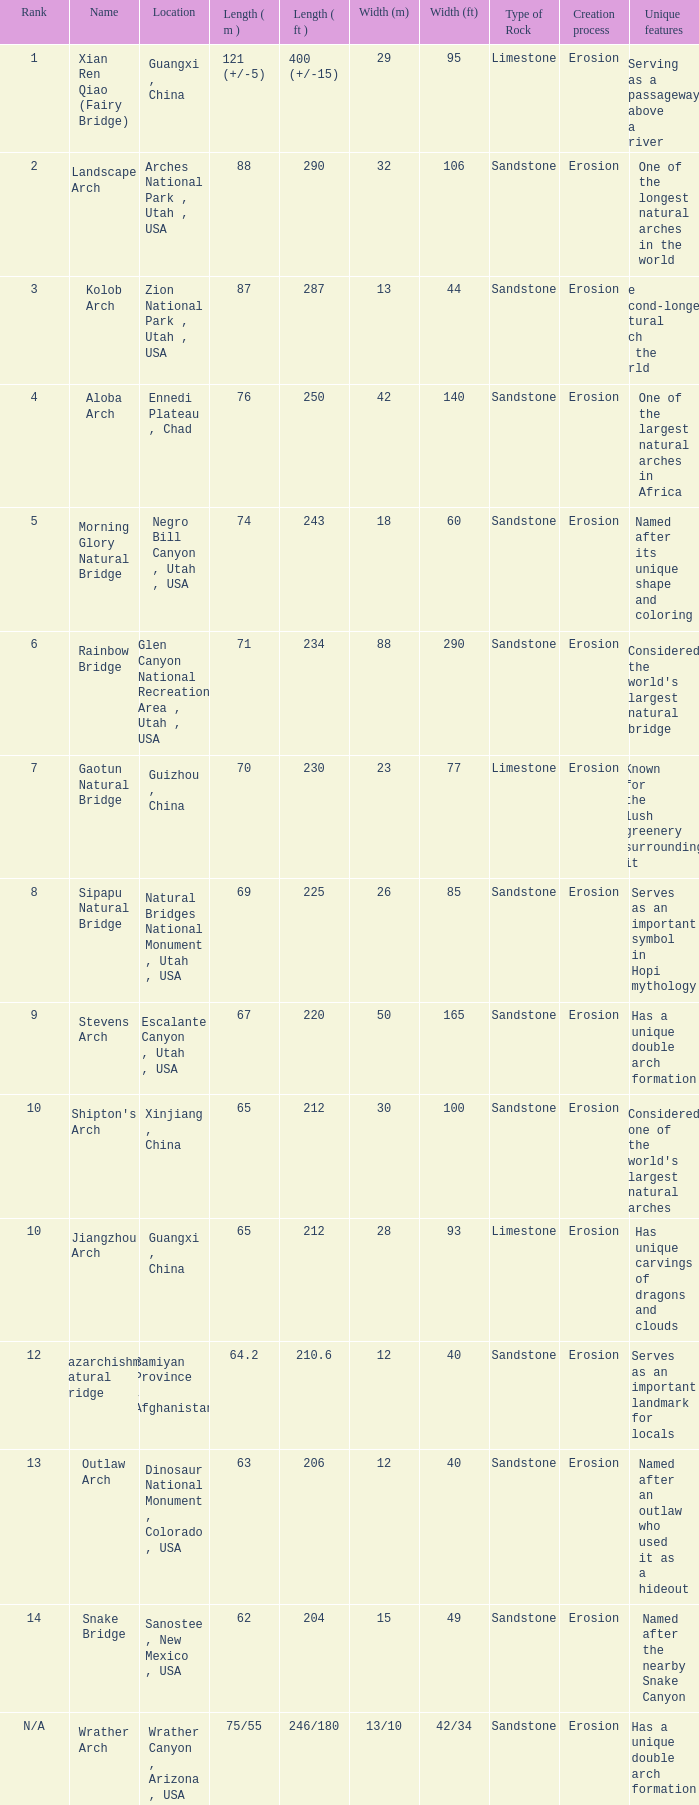What is the length in feet when the length in meters is 64.2? 210.6. 